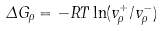Convert formula to latex. <formula><loc_0><loc_0><loc_500><loc_500>\Delta G _ { \rho } = - R T \ln ( v _ { \rho } ^ { + } / v _ { \rho } ^ { - } )</formula> 